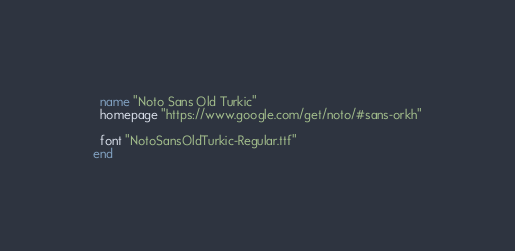Convert code to text. <code><loc_0><loc_0><loc_500><loc_500><_Ruby_>  name "Noto Sans Old Turkic"
  homepage "https://www.google.com/get/noto/#sans-orkh"

  font "NotoSansOldTurkic-Regular.ttf"
end
</code> 